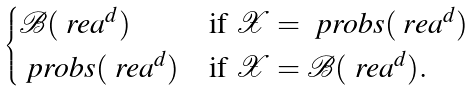<formula> <loc_0><loc_0><loc_500><loc_500>\begin{cases} \mathcal { B } ( \ r e a ^ { d } ) & \text {if } \mathcal { X } = \ p r o b s ( \ r e a ^ { d } ) \\ \ p r o b s ( \ r e a ^ { d } ) & \text {if } \mathcal { X } = \mathcal { B } ( \ r e a ^ { d } ) . \end{cases}</formula> 